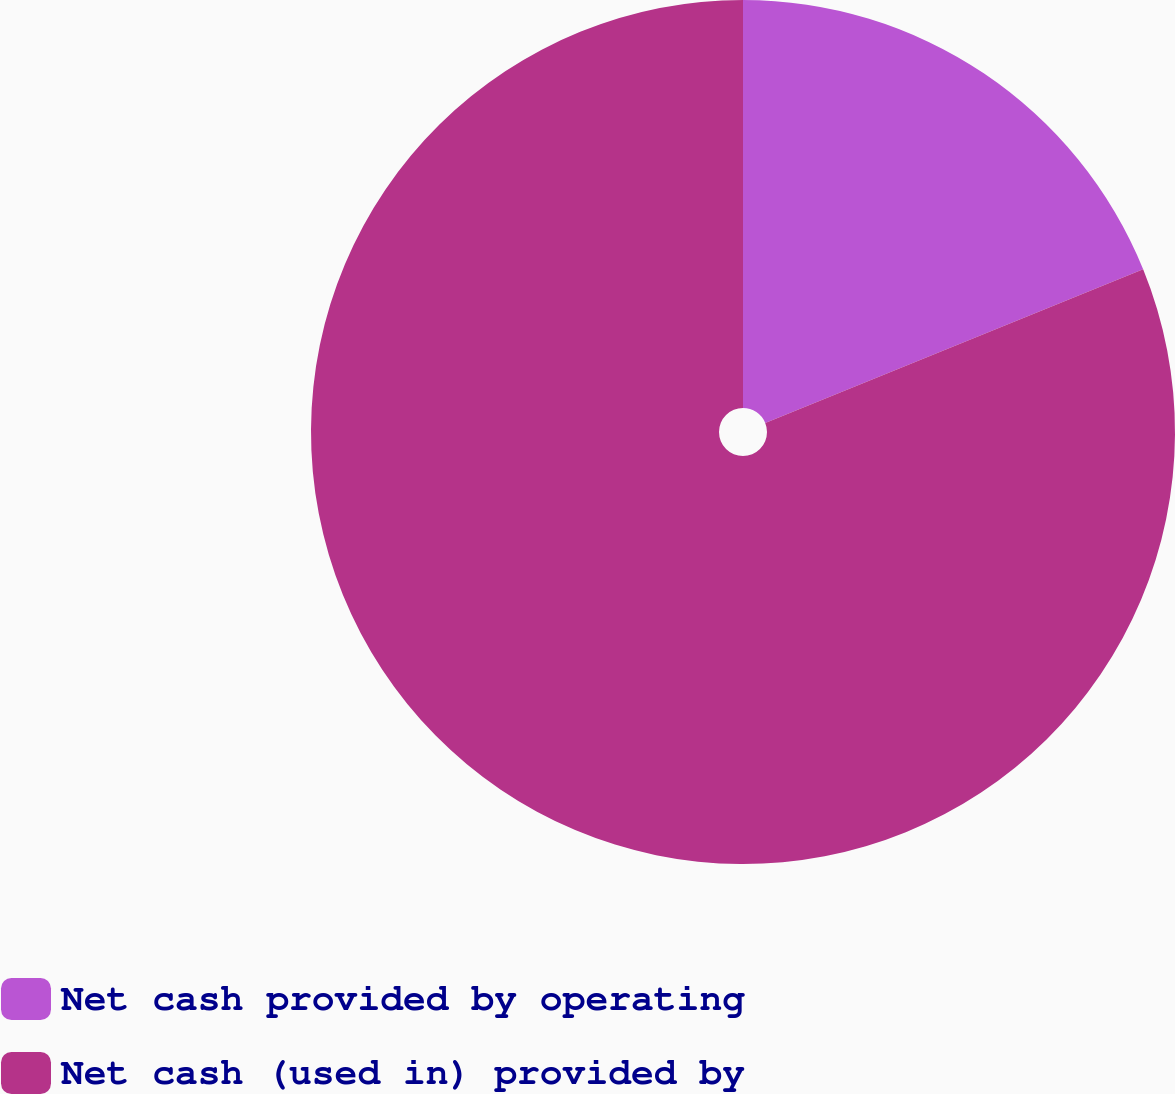<chart> <loc_0><loc_0><loc_500><loc_500><pie_chart><fcel>Net cash provided by operating<fcel>Net cash (used in) provided by<nl><fcel>18.85%<fcel>81.15%<nl></chart> 